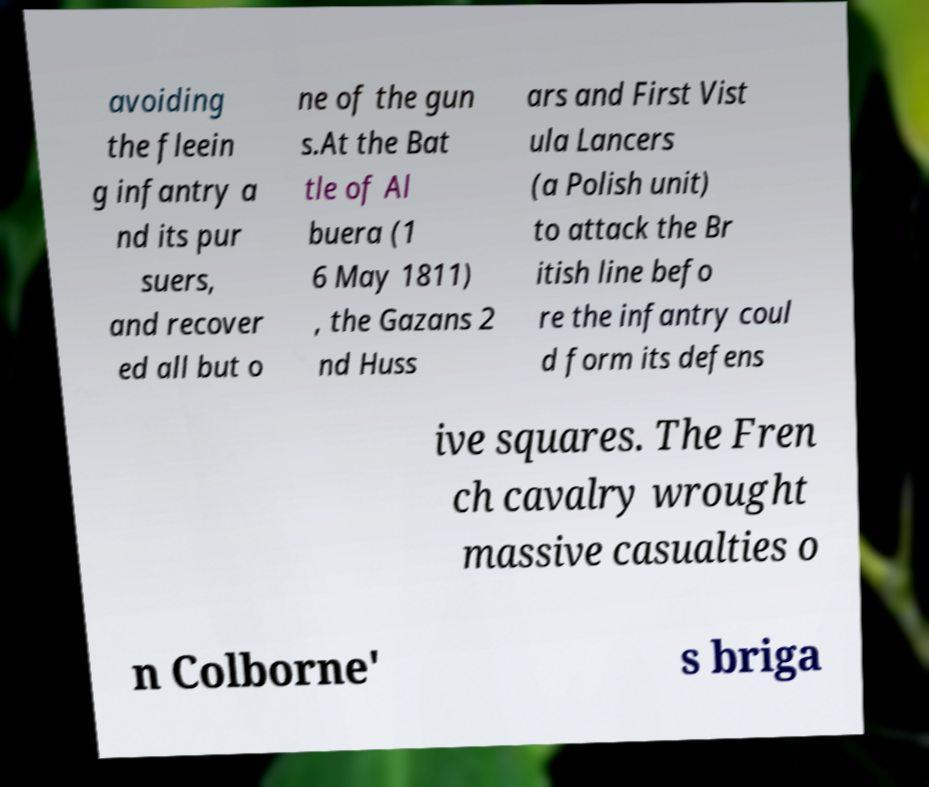Please read and relay the text visible in this image. What does it say? avoiding the fleein g infantry a nd its pur suers, and recover ed all but o ne of the gun s.At the Bat tle of Al buera (1 6 May 1811) , the Gazans 2 nd Huss ars and First Vist ula Lancers (a Polish unit) to attack the Br itish line befo re the infantry coul d form its defens ive squares. The Fren ch cavalry wrought massive casualties o n Colborne' s briga 